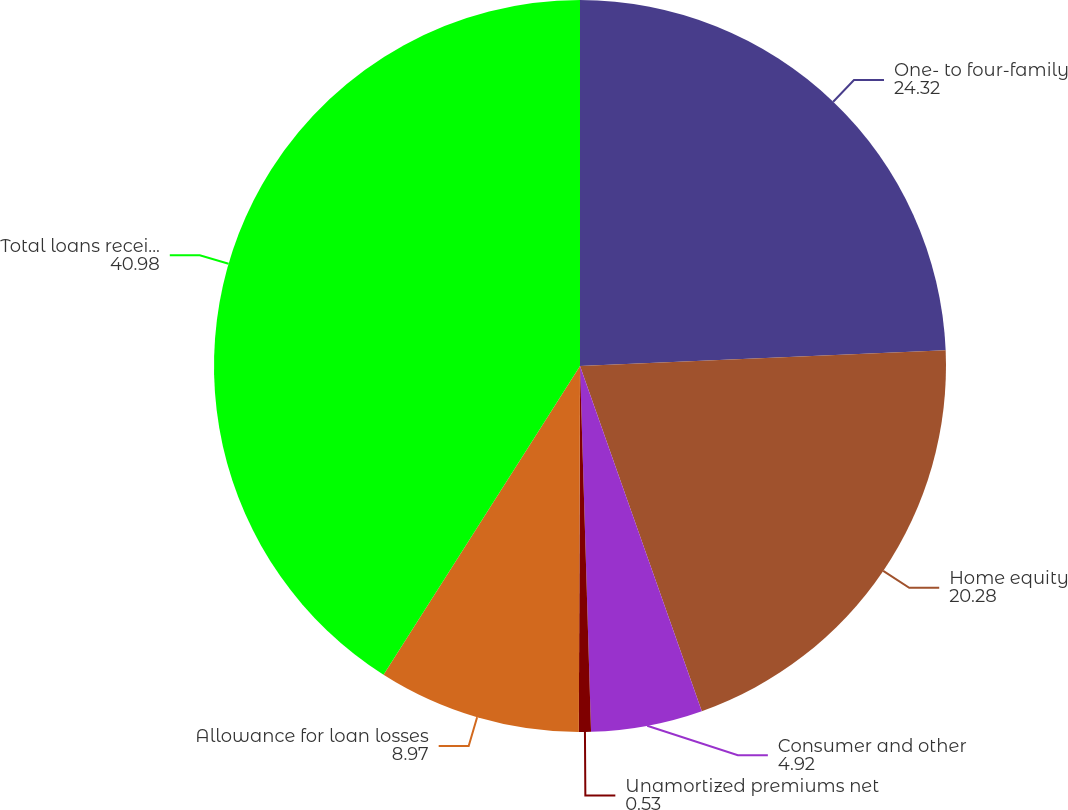Convert chart to OTSL. <chart><loc_0><loc_0><loc_500><loc_500><pie_chart><fcel>One- to four-family<fcel>Home equity<fcel>Consumer and other<fcel>Unamortized premiums net<fcel>Allowance for loan losses<fcel>Total loans receivable net<nl><fcel>24.32%<fcel>20.28%<fcel>4.92%<fcel>0.53%<fcel>8.97%<fcel>40.98%<nl></chart> 